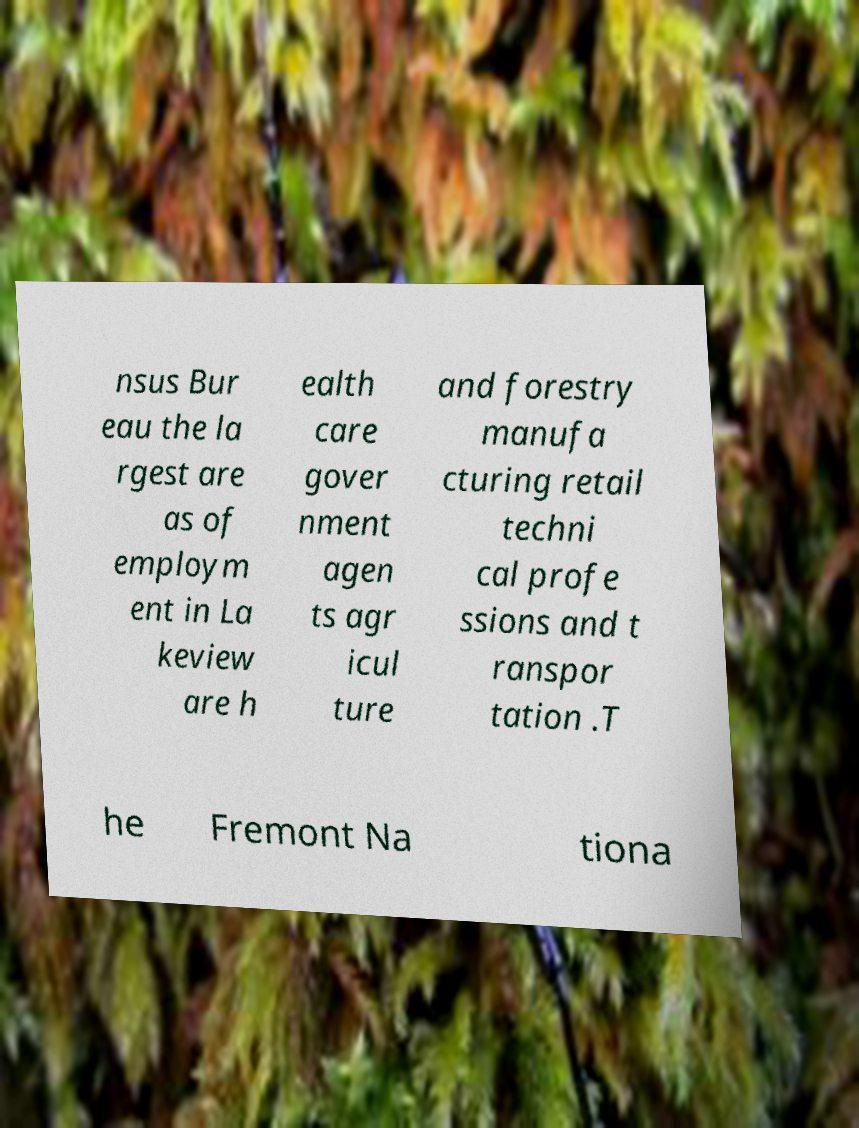There's text embedded in this image that I need extracted. Can you transcribe it verbatim? nsus Bur eau the la rgest are as of employm ent in La keview are h ealth care gover nment agen ts agr icul ture and forestry manufa cturing retail techni cal profe ssions and t ranspor tation .T he Fremont Na tiona 